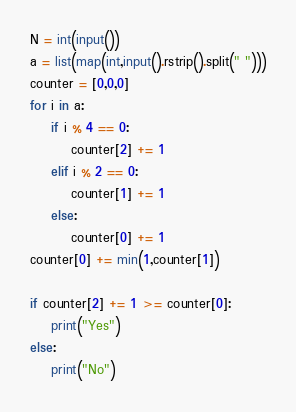Convert code to text. <code><loc_0><loc_0><loc_500><loc_500><_Python_>N = int(input())
a = list(map(int,input().rstrip().split(" ")))
counter = [0,0,0]
for i in a:
    if i % 4 == 0:
        counter[2] += 1
    elif i % 2 == 0:
        counter[1] += 1
    else:
        counter[0] += 1
counter[0] += min(1,counter[1])

if counter[2] += 1 >= counter[0]:
    print("Yes")
else:
    print("No")</code> 